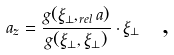Convert formula to latex. <formula><loc_0><loc_0><loc_500><loc_500>a _ { z } = \frac { g ( \xi _ { \perp } , _ { r e l } a ) } { g ( \xi _ { \perp } , \xi _ { \perp } ) } \cdot \xi _ { \perp } \text { \ ,}</formula> 